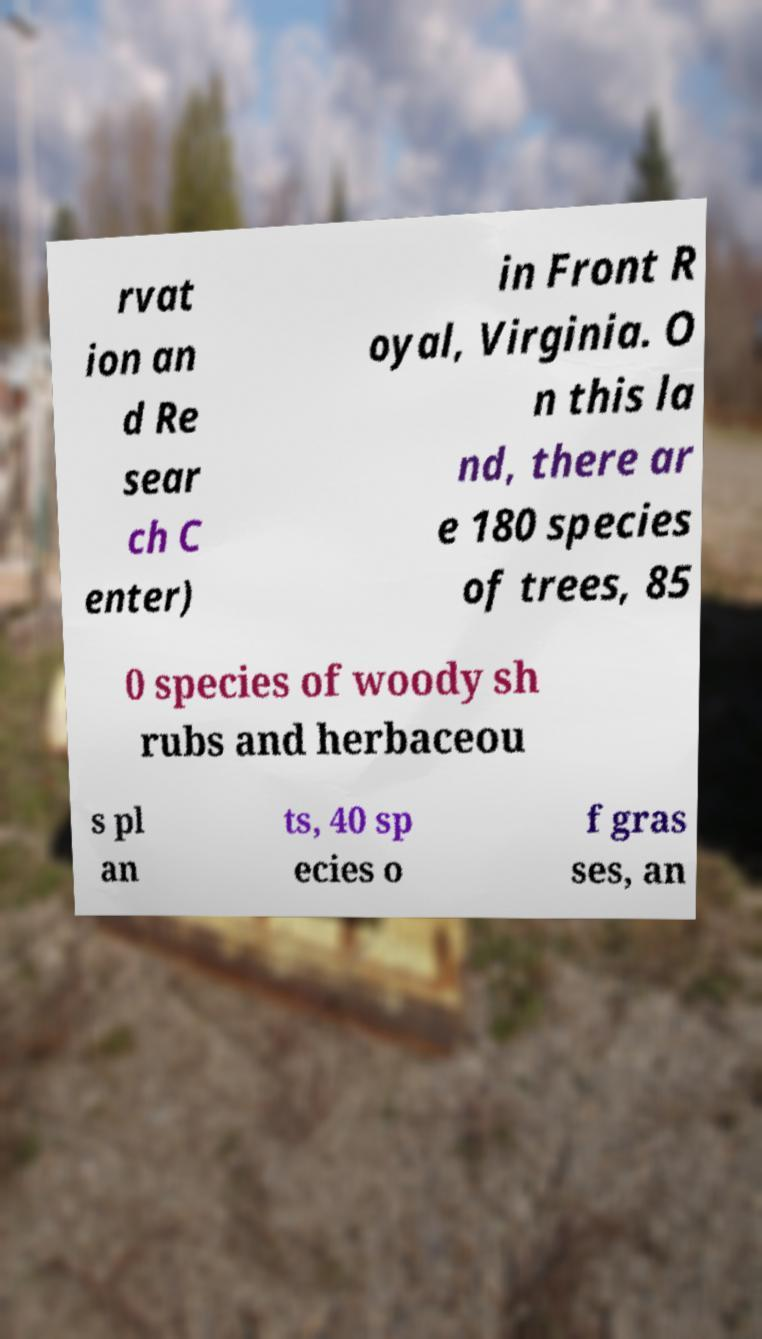Can you accurately transcribe the text from the provided image for me? rvat ion an d Re sear ch C enter) in Front R oyal, Virginia. O n this la nd, there ar e 180 species of trees, 85 0 species of woody sh rubs and herbaceou s pl an ts, 40 sp ecies o f gras ses, an 